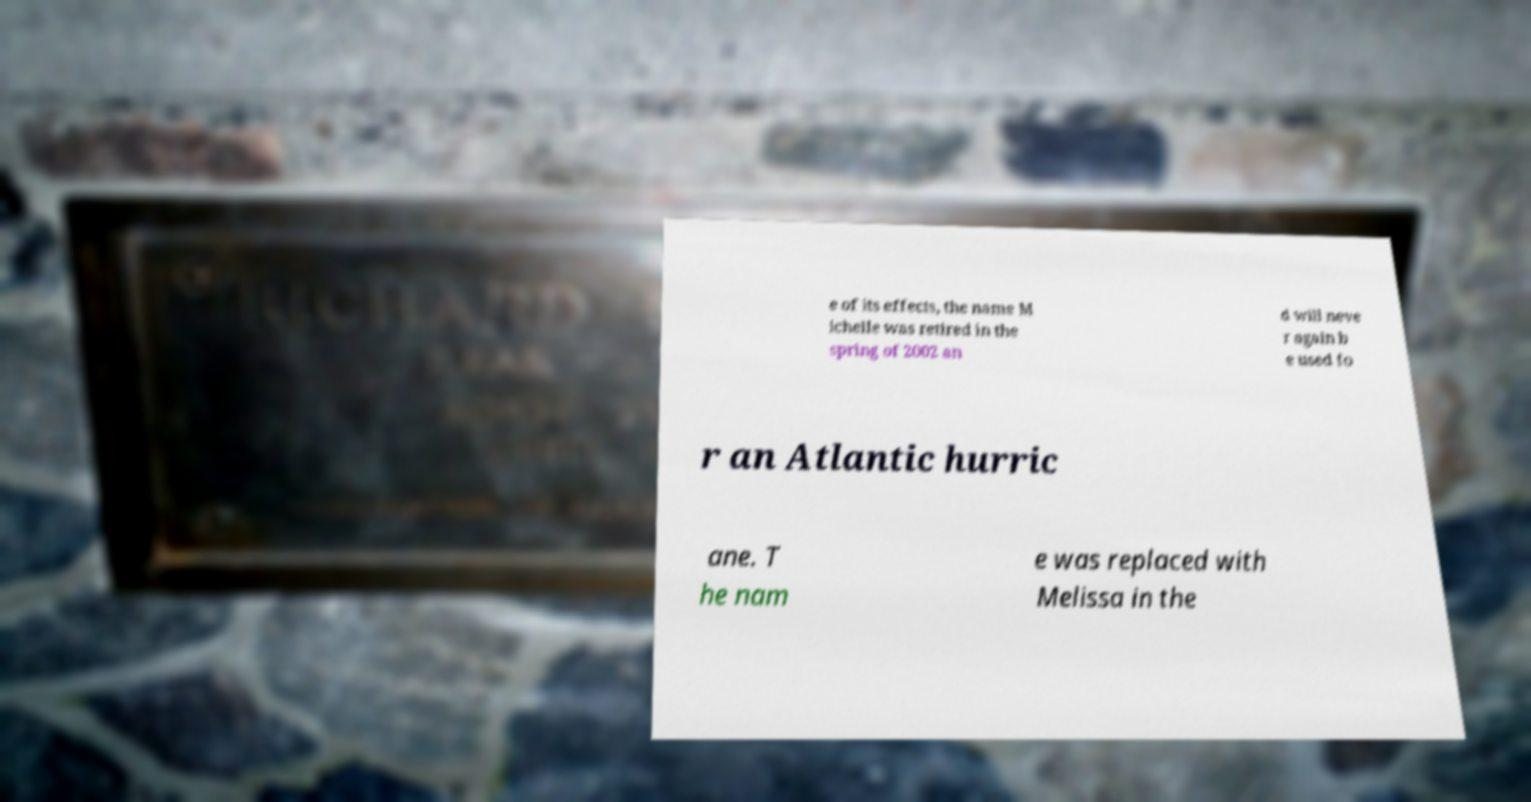I need the written content from this picture converted into text. Can you do that? e of its effects, the name M ichelle was retired in the spring of 2002 an d will neve r again b e used fo r an Atlantic hurric ane. T he nam e was replaced with Melissa in the 